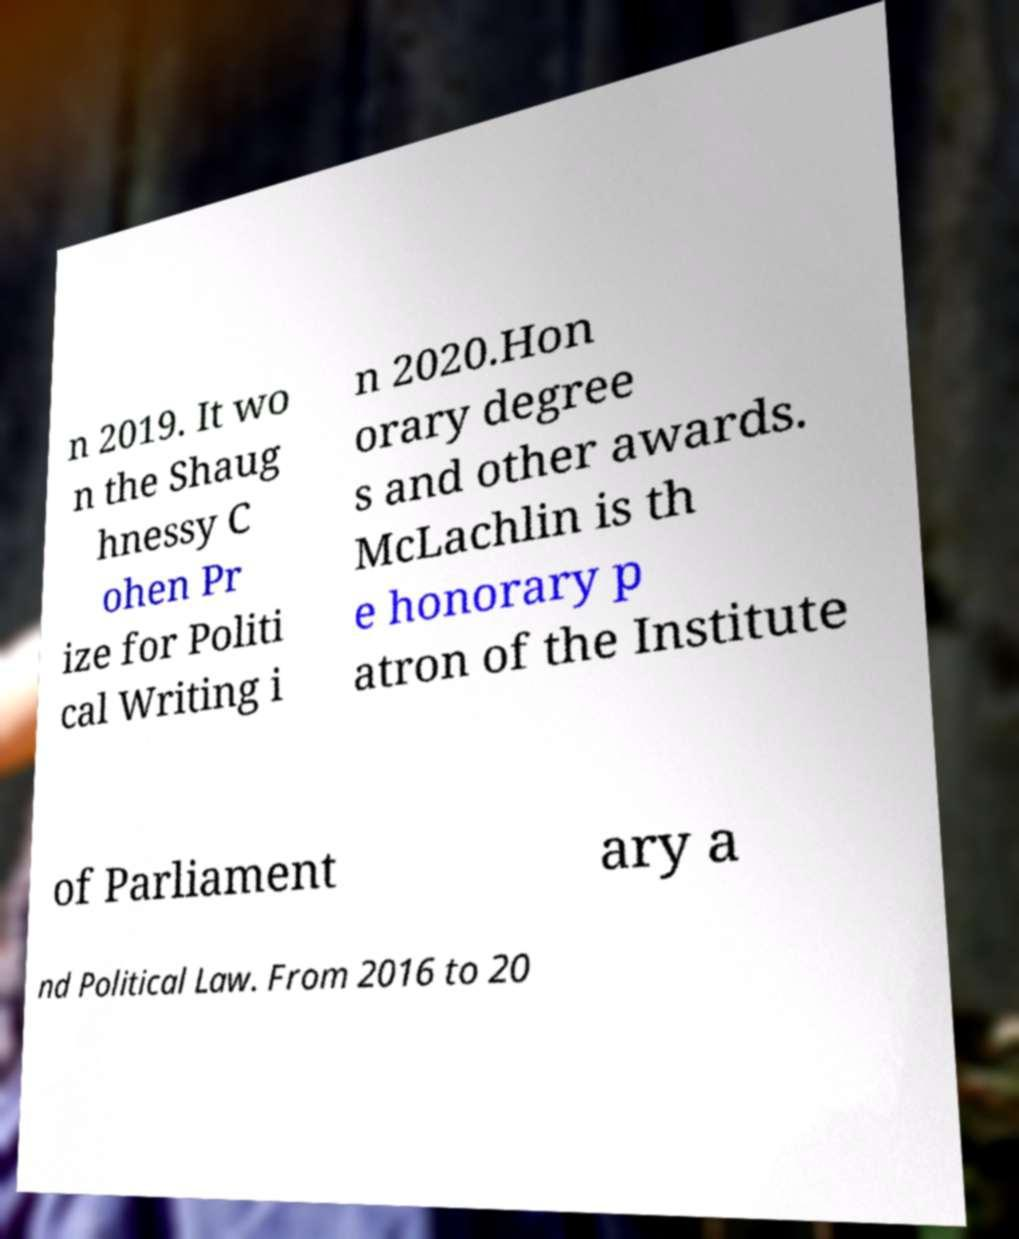There's text embedded in this image that I need extracted. Can you transcribe it verbatim? n 2019. It wo n the Shaug hnessy C ohen Pr ize for Politi cal Writing i n 2020.Hon orary degree s and other awards. McLachlin is th e honorary p atron of the Institute of Parliament ary a nd Political Law. From 2016 to 20 